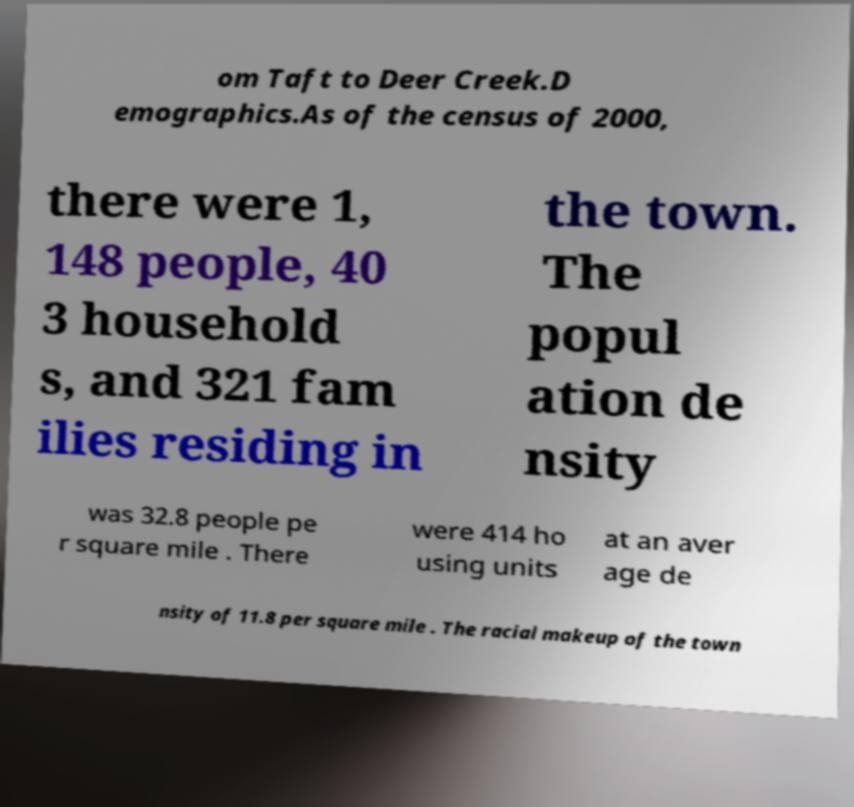For documentation purposes, I need the text within this image transcribed. Could you provide that? om Taft to Deer Creek.D emographics.As of the census of 2000, there were 1, 148 people, 40 3 household s, and 321 fam ilies residing in the town. The popul ation de nsity was 32.8 people pe r square mile . There were 414 ho using units at an aver age de nsity of 11.8 per square mile . The racial makeup of the town 